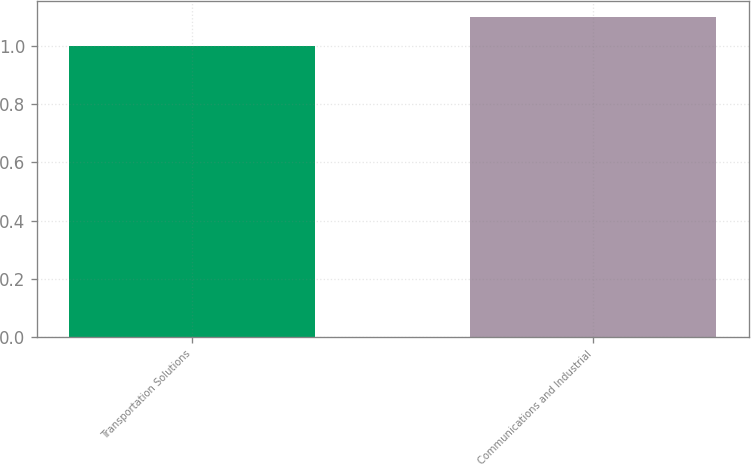Convert chart. <chart><loc_0><loc_0><loc_500><loc_500><bar_chart><fcel>Transportation Solutions<fcel>Communications and Industrial<nl><fcel>1<fcel>1.1<nl></chart> 